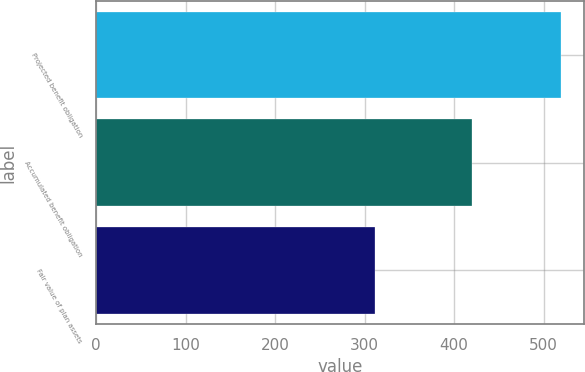<chart> <loc_0><loc_0><loc_500><loc_500><bar_chart><fcel>Projected benefit obligation<fcel>Accumulated benefit obligation<fcel>Fair value of plan assets<nl><fcel>519<fcel>420<fcel>312<nl></chart> 